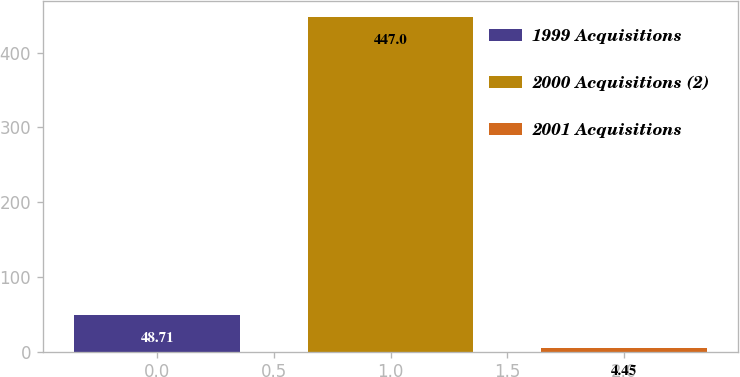<chart> <loc_0><loc_0><loc_500><loc_500><bar_chart><fcel>1999 Acquisitions<fcel>2000 Acquisitions (2)<fcel>2001 Acquisitions<nl><fcel>48.71<fcel>447<fcel>4.45<nl></chart> 